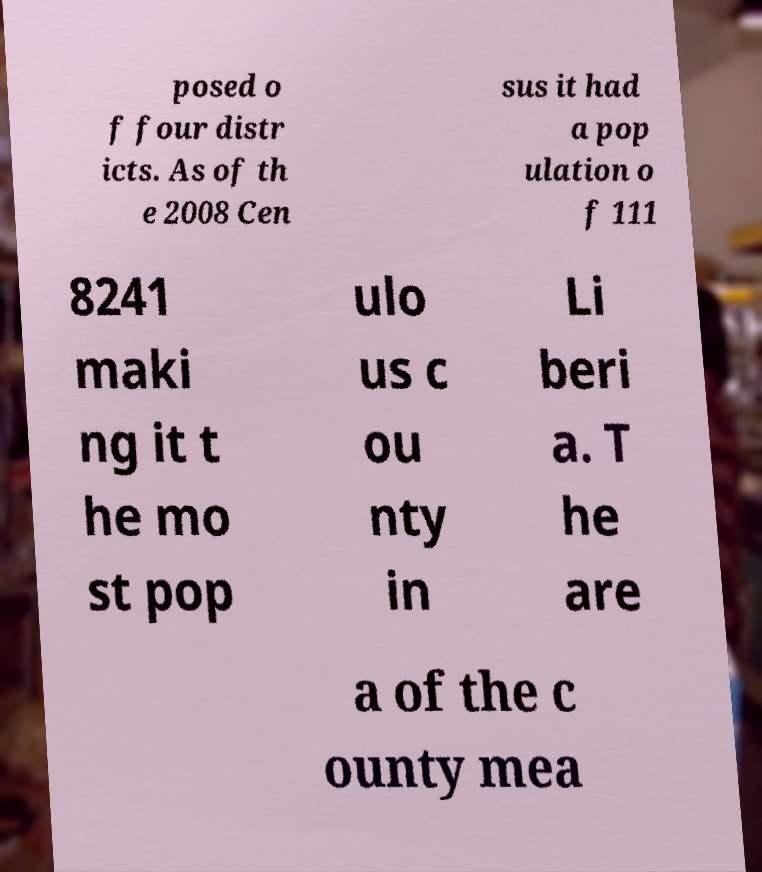Please identify and transcribe the text found in this image. posed o f four distr icts. As of th e 2008 Cen sus it had a pop ulation o f 111 8241 maki ng it t he mo st pop ulo us c ou nty in Li beri a. T he are a of the c ounty mea 